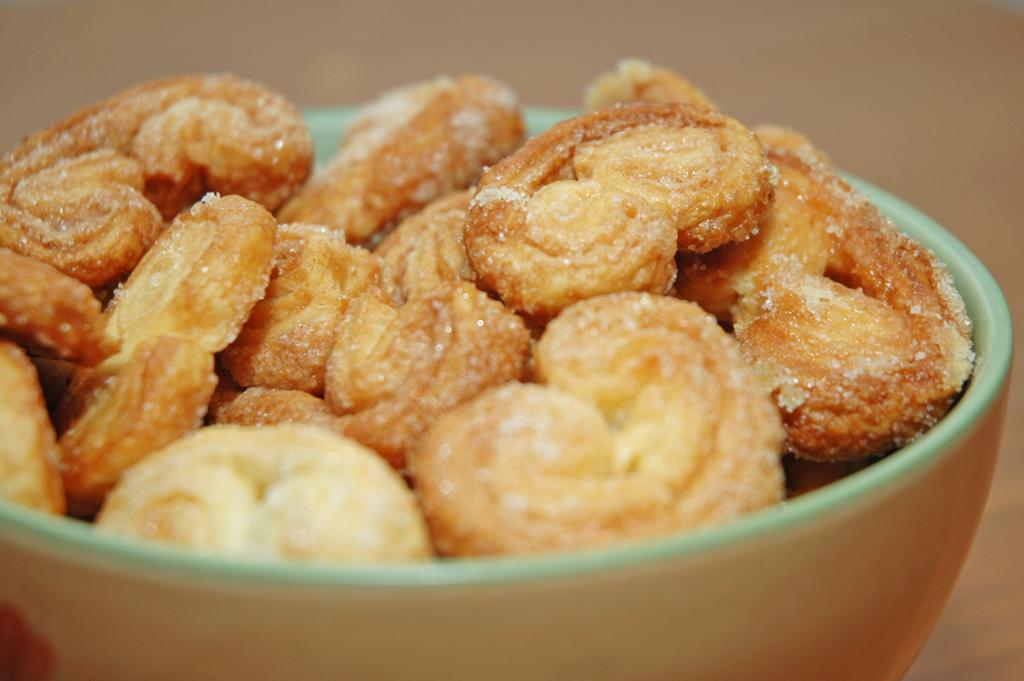What is in the bowl that is visible in the image? There is a bowl in the image, and it is full of cookies. What type of rice can be seen in the bowl in the image? There is no rice present in the image; the bowl is full of cookies. How many mittens are visible in the image? There are no mittens present in the image. 